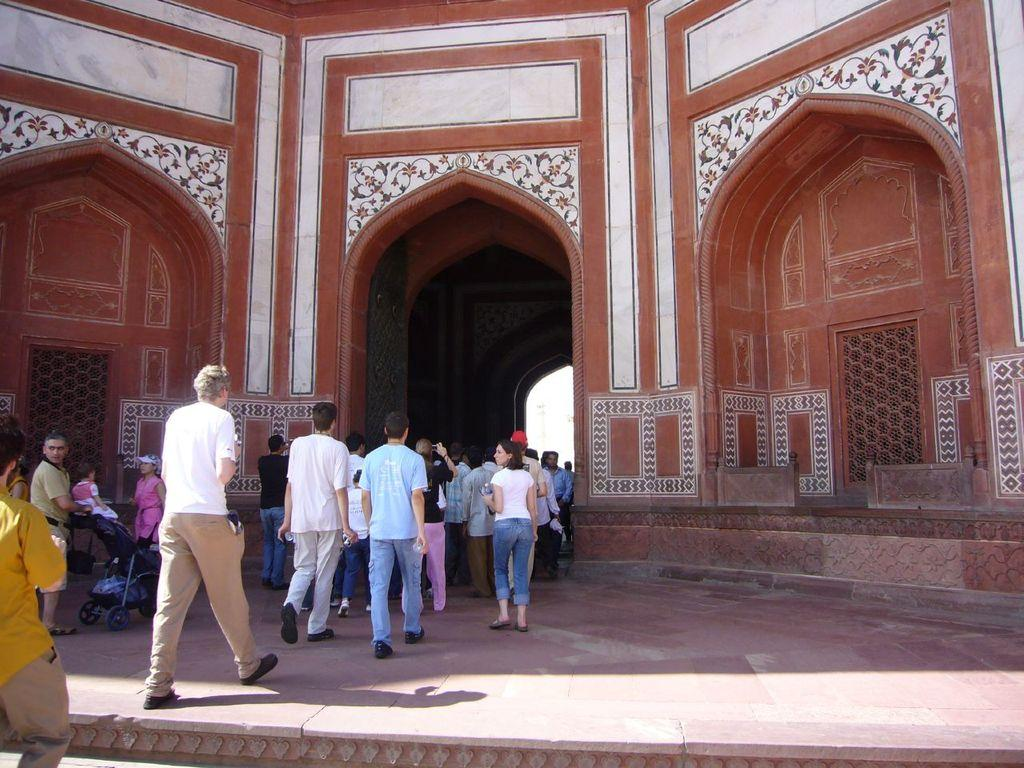What are the people in the foreground of the picture doing? The people in the foreground of the picture are walking. What can be seen beneath the people's feet in the foreground? There is a floor visible in the foreground. What is the main subject in the center of the picture? There is a monument in the center of the picture. What colors are the walls of the monument? The walls of the monument have red and white colors. Are there any stockings hanging from the monument in the image? There is no mention of stockings in the image, and they are not visible in the monument. Can you see any waves in the image? There are no waves visible in the image, as it features people walking, a floor, a monument, and its red and white walls. 